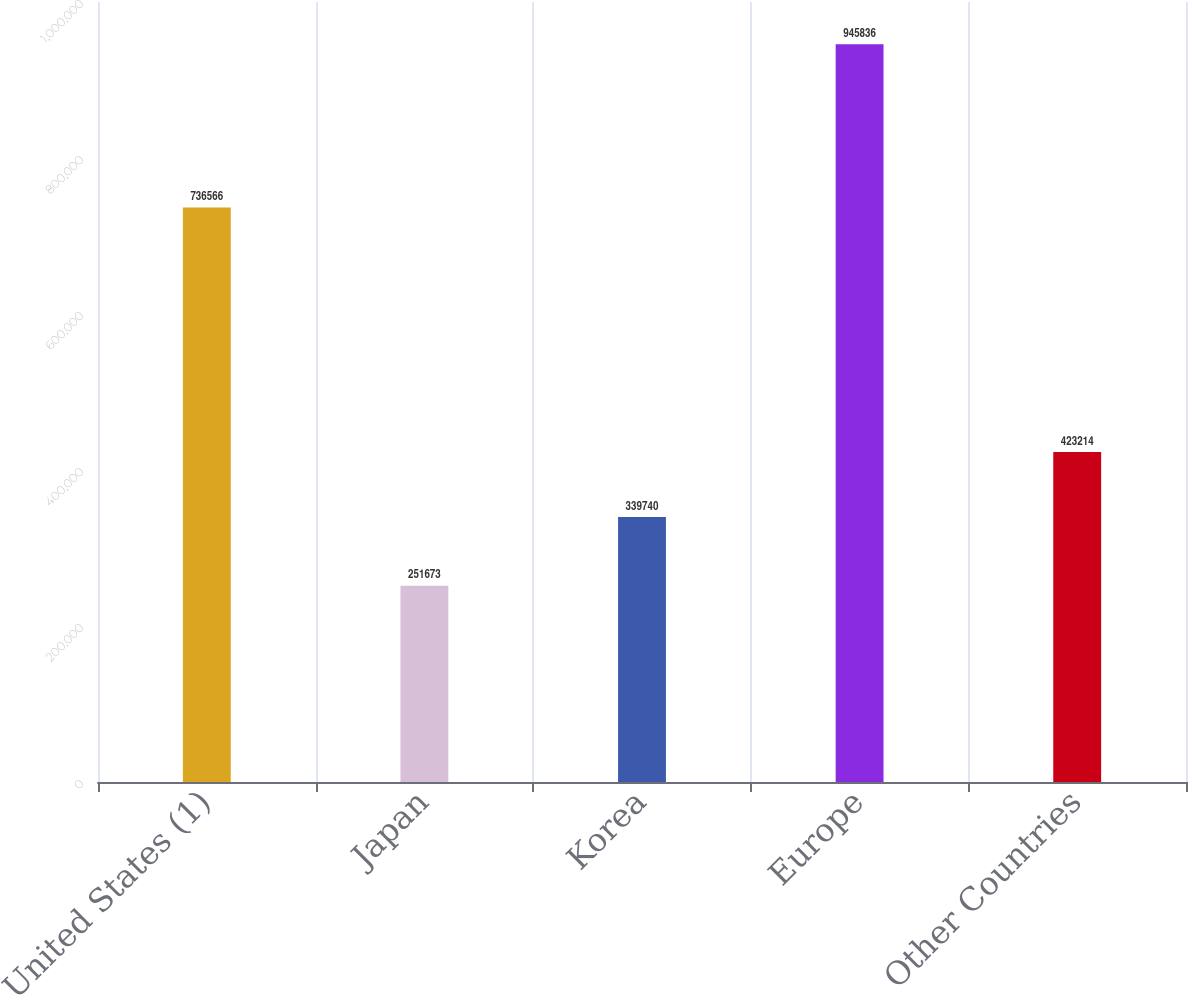Convert chart to OTSL. <chart><loc_0><loc_0><loc_500><loc_500><bar_chart><fcel>United States (1)<fcel>Japan<fcel>Korea<fcel>Europe<fcel>Other Countries<nl><fcel>736566<fcel>251673<fcel>339740<fcel>945836<fcel>423214<nl></chart> 